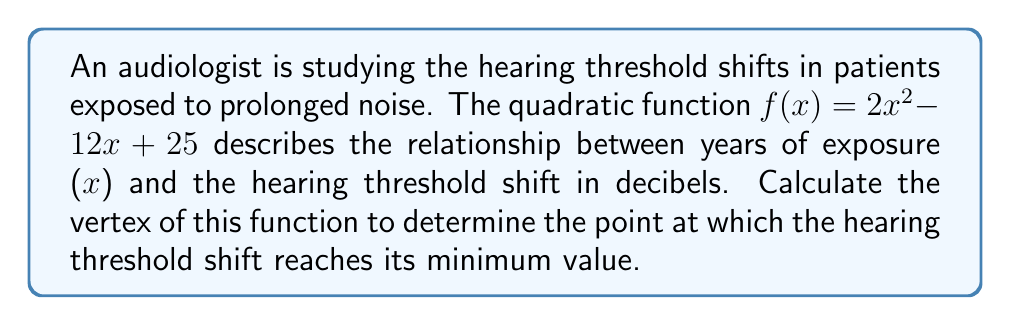Solve this math problem. To find the vertex of a quadratic function in the form $f(x) = ax^2 + bx + c$, we can use the formula:

$$x = -\frac{b}{2a}$$

Where $a$ and $b$ are the coefficients of the quadratic function.

For the given function $f(x) = 2x^2 - 12x + 25$:
$a = 2$
$b = -12$
$c = 25$

Substituting these values into the formula:

$$x = -\frac{(-12)}{2(2)} = \frac{12}{4} = 3$$

This gives us the x-coordinate of the vertex.

To find the y-coordinate, we substitute x = 3 into the original function:

$$\begin{align}
f(3) &= 2(3)^2 - 12(3) + 25 \\
&= 2(9) - 36 + 25 \\
&= 18 - 36 + 25 \\
&= 7
\end{align}$$

Therefore, the vertex of the quadratic function is (3, 7).
Answer: The vertex of the quadratic function is (3, 7). 